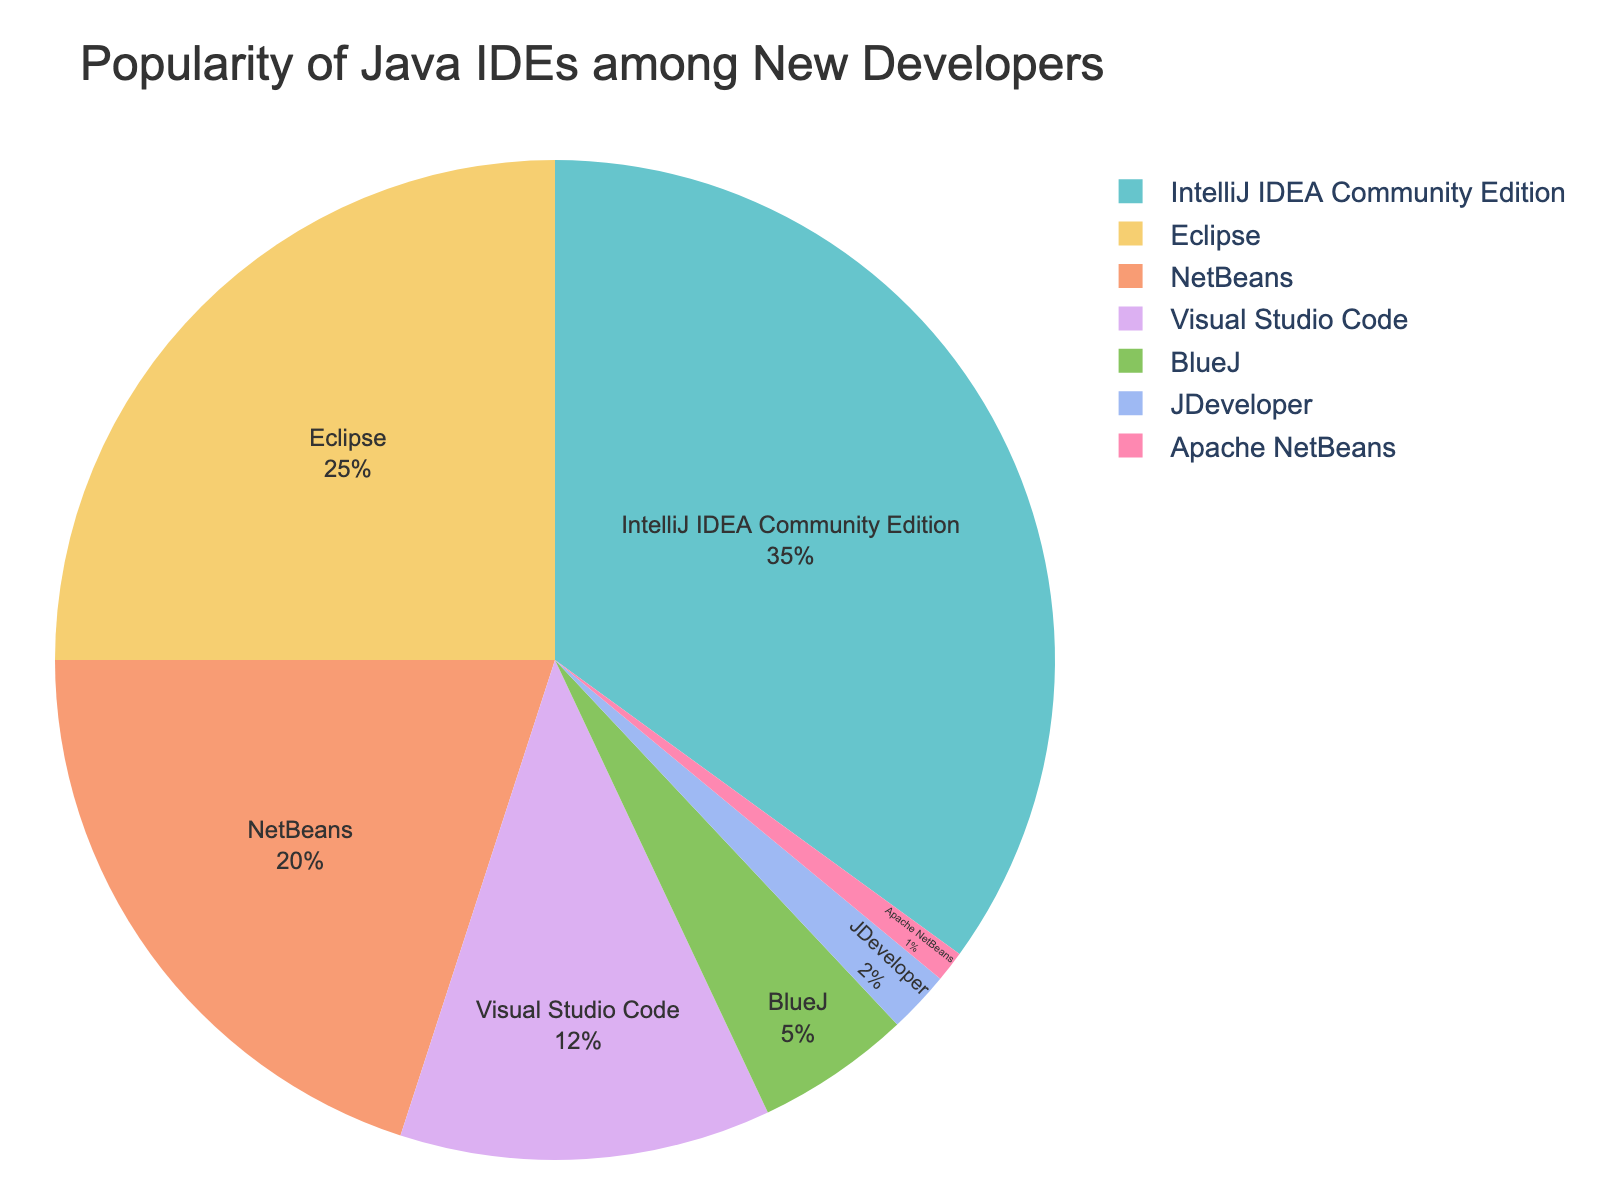What is the most popular Java IDE among new developers? The figure shows a pie chart with different IDEs and their usage percentages. The largest slice represents the most popular IDE. According to the chart, IntelliJ IDEA Community Edition has the largest slice at 35%.
Answer: IntelliJ IDEA Community Edition Which IDE is used by exactly 20% of new developers? By looking at the slices of the pie chart, each slice is labeled with the IDE and its corresponding usage percentage. The IDE with a 20% usage is NetBeans.
Answer: NetBeans What is the combined usage percentage of Eclipse and Visual Studio Code? The figure indicates that Eclipse has a 25% usage and Visual Studio Code has 12%. By adding these two percentages together (25 + 12), we get the combined usage.
Answer: 37% Which IDEs have a usage percentage less than 10%? The pie chart shows labels with usage percentages. The IDEs with usage percentages less than 10% are BlueJ, JDeveloper, and Apache NetBeans.
Answer: BlueJ, JDeveloper, Apache NetBeans How much more popular is IntelliJ IDEA Community Edition compared to NetBeans? The pie chart shows IntelliJ IDEA Community Edition at 35% and NetBeans at 20%. The difference in popularity is found by subtracting 20 from 35.
Answer: 15% Is Visual Studio Code more or less popular than BlueJ? The pie chart shows the usage percentages of Visual Studio Code at 12% and BlueJ at 5%. Comparing these two values, Visual Studio Code is more popular.
Answer: More popular What is the average usage percentage of Eclipse, NetBeans, and JDeveloper? The chart shows the percentages of Eclipse (25%), NetBeans (20%), and JDeveloper (2%). To find the average, add the three percentages (25 + 20 + 2 = 47) and then divide by 3.
Answer: 15.67% Which IDE has the smallest slice in the pie chart? By examining the pie chart, the smallest slice corresponds to the IDE with the lowest usage percentage. Apache NetBeans has the smallest slice with a 1% usage.
Answer: Apache NetBeans How do IntelliJ IDEA Community Edition and Eclipse together compare to the sum of Visual Studio Code and BlueJ? The chart shows percentages for IntelliJ IDEA Community Edition (35%) and Eclipse (25%), summing these gives 60%. For Visual Studio Code (12%) and BlueJ (5%), the sum is 17%. Comparing these, 60% is much larger than 17%.
Answer: 60% (IntelliJ IDEA Community Edition + Eclipse) is larger than 17% (Visual Studio Code + BlueJ) How much more popular is Eclipse than Apache NetBeans, in terms of percentage points? The pie chart shows Eclipse with a 25% usage and Apache NetBeans with 1% usage. Subtracting these percentages (25 - 1), Eclipse is more popular by 24 percentage points.
Answer: 24 percentage points 